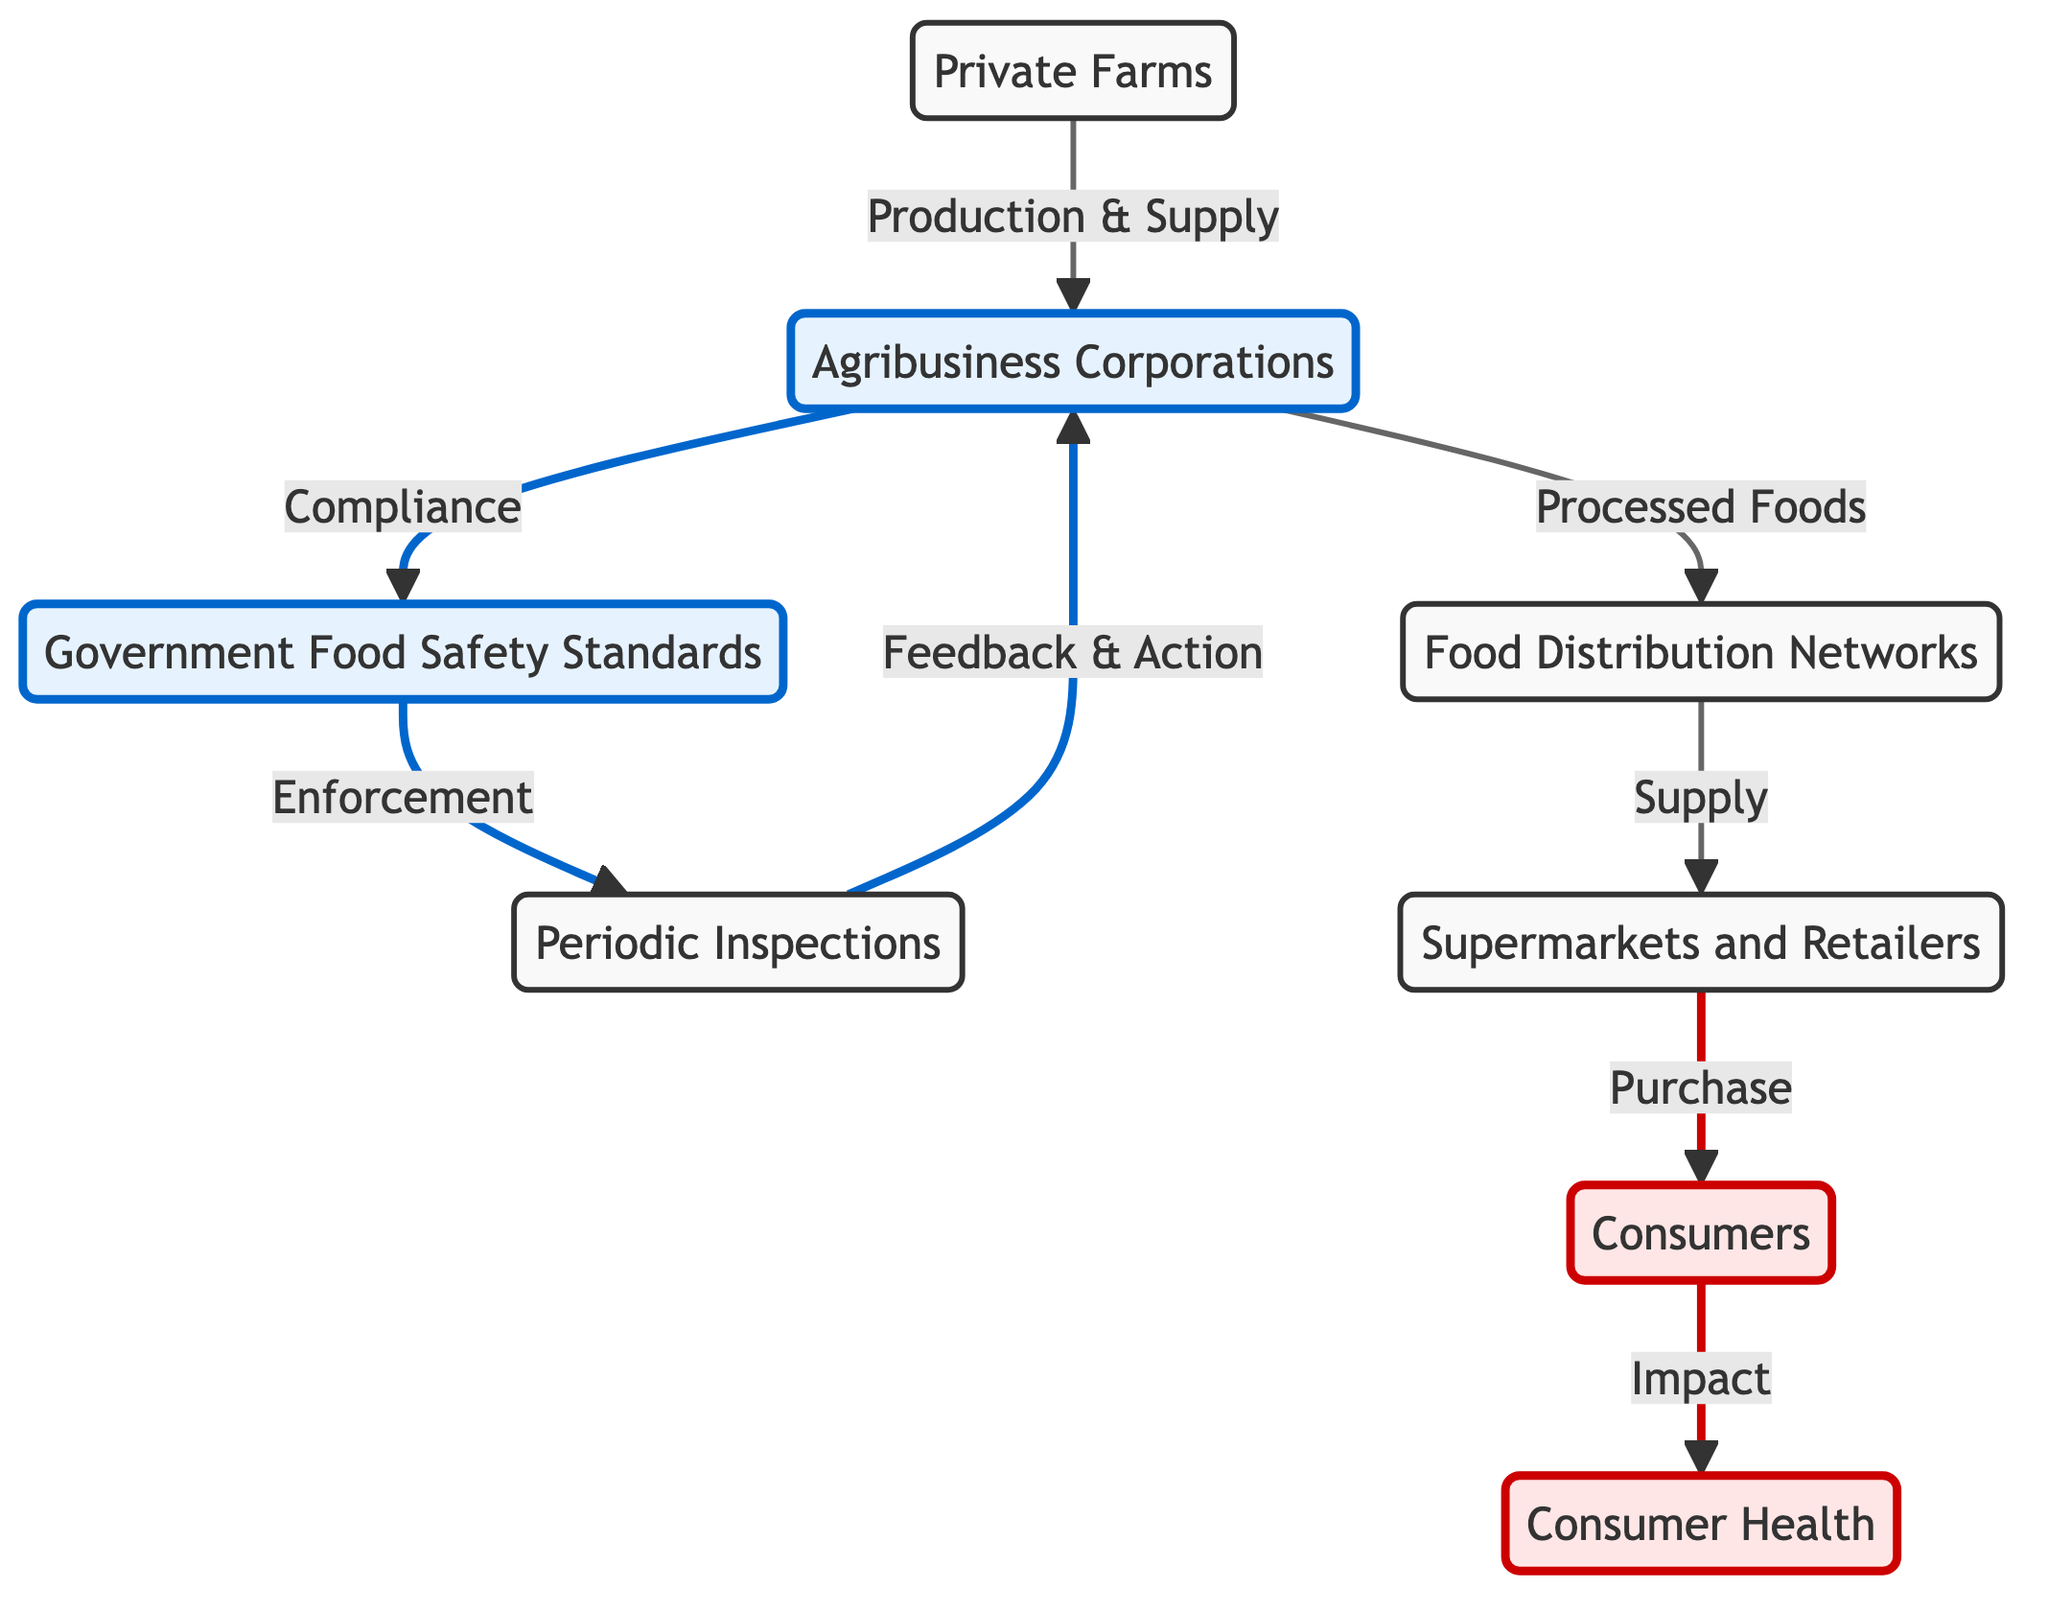What is the starting point of the food chain? The food chain begins with the "Private Farms" node, which is the source of production and supply.
Answer: Private Farms How many main nodes are there in the diagram? By counting the distinct nodes in the diagram, we find there are seven main nodes: Private Farms, Agribusiness Corporations, Government Food Safety Standards, Periodic Inspections, Food Distribution Networks, Supermarkets and Retailers, and Consumers.
Answer: 7 What role do Agribusiness Corporations play in relation to regulations? Agribusiness Corporations are responsible for compliance with the Government Food Safety Standards according to the flow shown in the diagram.
Answer: Compliance What follows the “Periodic Inspections” node in the flow? After the "Periodic Inspections" node, the flow leads to "Agribusiness Corporations," which indicates that inspections provide feedback and necessary actions to these businesses.
Answer: Agribusiness Corporations What is the effect of food being purchased by consumers? The flow indicates that the final impact of consumers purchasing food is on "Consumer Health," demonstrating how consumer interactions with the food chain affect health outcomes.
Answer: Consumer Health How does feedback influence Agribusiness Corporations? The feedback from "Periodic Inspections" leads to actions taken by Agribusiness Corporations, indicating that inspections can prompt changes in practices or compliance by these entities.
Answer: Feedback & Action What is the relationship between food distribution and consumers? The relationship shown indicates that "Food Distribution Networks" supply food to "Supermarkets and Retailers," which are then purchased by "Consumers," demonstrating a direct supply chain link.
Answer: Supply Which node indicates enforcement of food safety? The "Government Food Safety Standards" node includes an arrow pointing to "Periodic Inspections," which indicates enforcement of these standards through periodic checks.
Answer: Government Food Safety Standards 